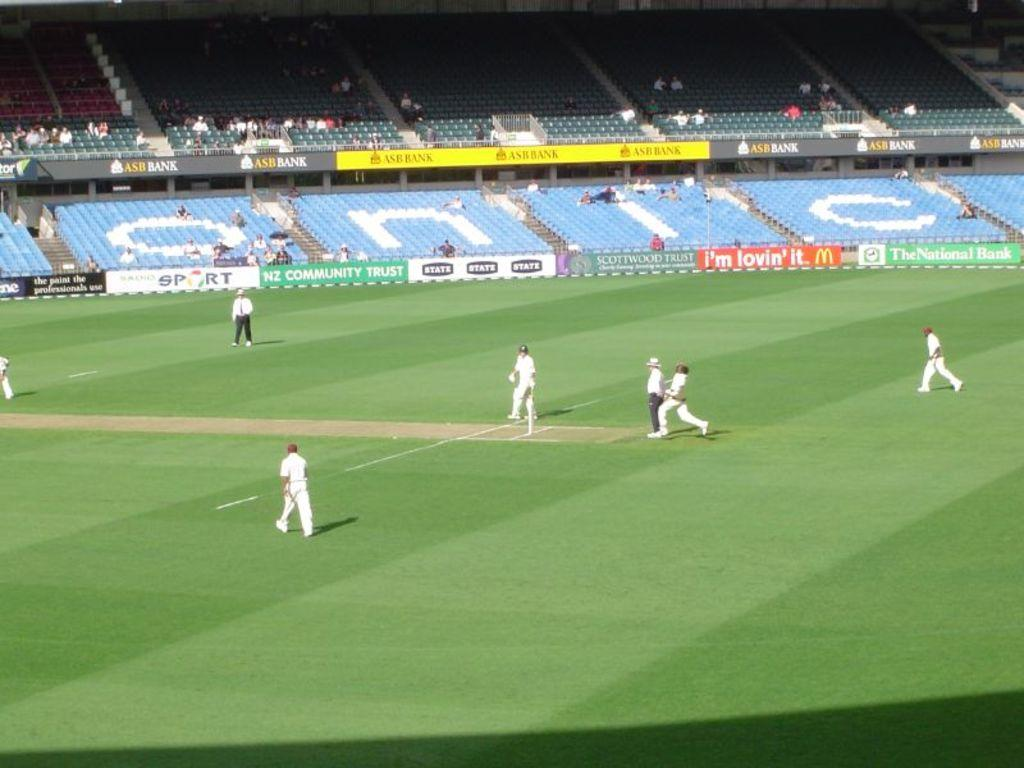Provide a one-sentence caption for the provided image. a group of players playing soccer next to bleachers that read onic. 